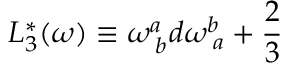<formula> <loc_0><loc_0><loc_500><loc_500>L _ { 3 } ^ { * } ( \omega ) \equiv \omega _ { \, b } ^ { a } d \omega _ { \, a } ^ { b } + \frac { 2 } { 3 }</formula> 